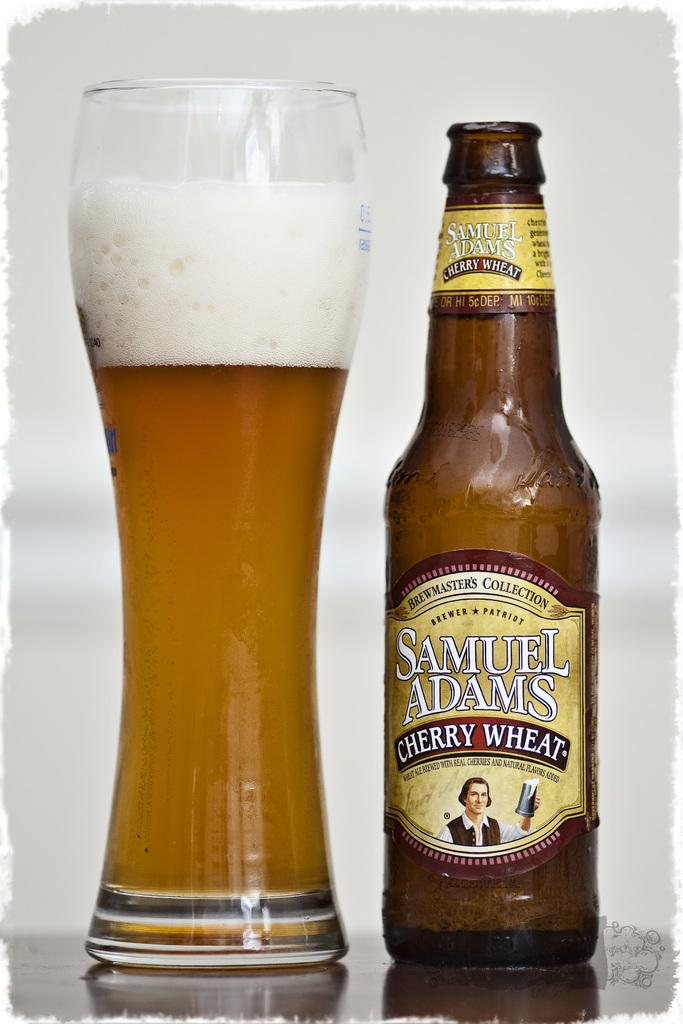<image>
Describe the image concisely. the word samuel is next to a beer glass 